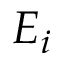<formula> <loc_0><loc_0><loc_500><loc_500>E _ { i }</formula> 